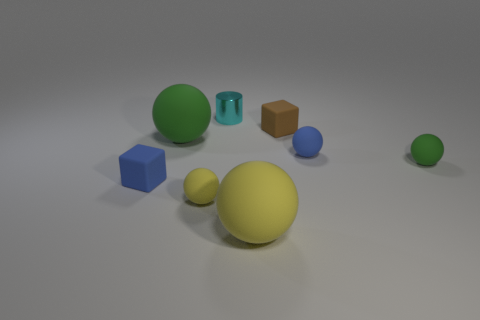There is a yellow ball on the right side of the tiny yellow sphere; are there any cylinders in front of it?
Your response must be concise. No. What number of spheres are either small cyan objects or tiny green matte things?
Give a very brief answer. 1. What is the size of the yellow matte sphere to the right of the metallic cylinder that is behind the cube that is behind the tiny green sphere?
Give a very brief answer. Large. There is a small metal cylinder; are there any green rubber things on the right side of it?
Offer a very short reply. Yes. How many objects are either small objects that are behind the brown rubber thing or big yellow matte things?
Your answer should be very brief. 2. What size is the blue block that is made of the same material as the small blue sphere?
Provide a succinct answer. Small. Do the blue matte sphere and the rubber block in front of the tiny green rubber object have the same size?
Provide a short and direct response. Yes. What is the color of the thing that is both left of the shiny cylinder and in front of the small blue matte cube?
Ensure brevity in your answer.  Yellow. What number of objects are yellow objects on the left side of the cylinder or green rubber objects right of the tiny blue matte ball?
Provide a short and direct response. 2. The cube left of the rubber cube that is right of the tiny blue rubber object on the left side of the cylinder is what color?
Your response must be concise. Blue. 